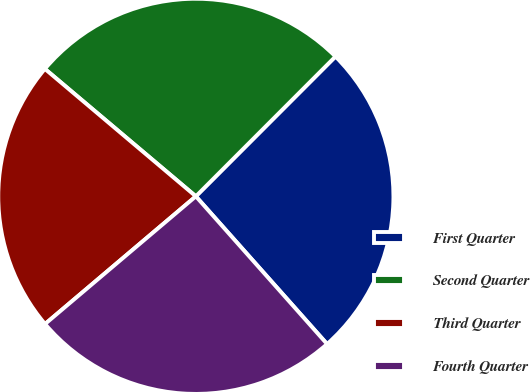Convert chart. <chart><loc_0><loc_0><loc_500><loc_500><pie_chart><fcel>First Quarter<fcel>Second Quarter<fcel>Third Quarter<fcel>Fourth Quarter<nl><fcel>25.95%<fcel>26.33%<fcel>22.34%<fcel>25.38%<nl></chart> 